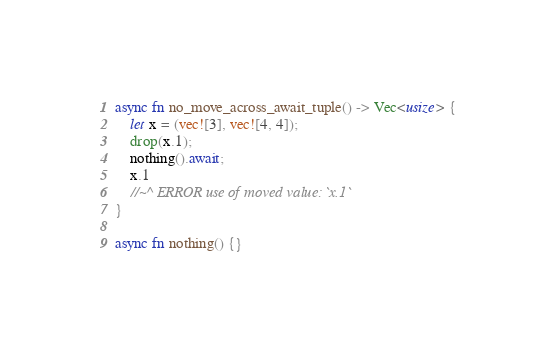Convert code to text. <code><loc_0><loc_0><loc_500><loc_500><_Rust_>
async fn no_move_across_await_tuple() -> Vec<usize> {
    let x = (vec![3], vec![4, 4]);
    drop(x.1);
    nothing().await;
    x.1
    //~^ ERROR use of moved value: `x.1`
}

async fn nothing() {}
</code> 